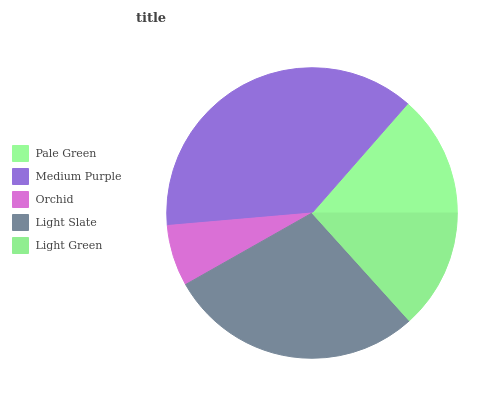Is Orchid the minimum?
Answer yes or no. Yes. Is Medium Purple the maximum?
Answer yes or no. Yes. Is Medium Purple the minimum?
Answer yes or no. No. Is Orchid the maximum?
Answer yes or no. No. Is Medium Purple greater than Orchid?
Answer yes or no. Yes. Is Orchid less than Medium Purple?
Answer yes or no. Yes. Is Orchid greater than Medium Purple?
Answer yes or no. No. Is Medium Purple less than Orchid?
Answer yes or no. No. Is Pale Green the high median?
Answer yes or no. Yes. Is Pale Green the low median?
Answer yes or no. Yes. Is Light Slate the high median?
Answer yes or no. No. Is Light Slate the low median?
Answer yes or no. No. 